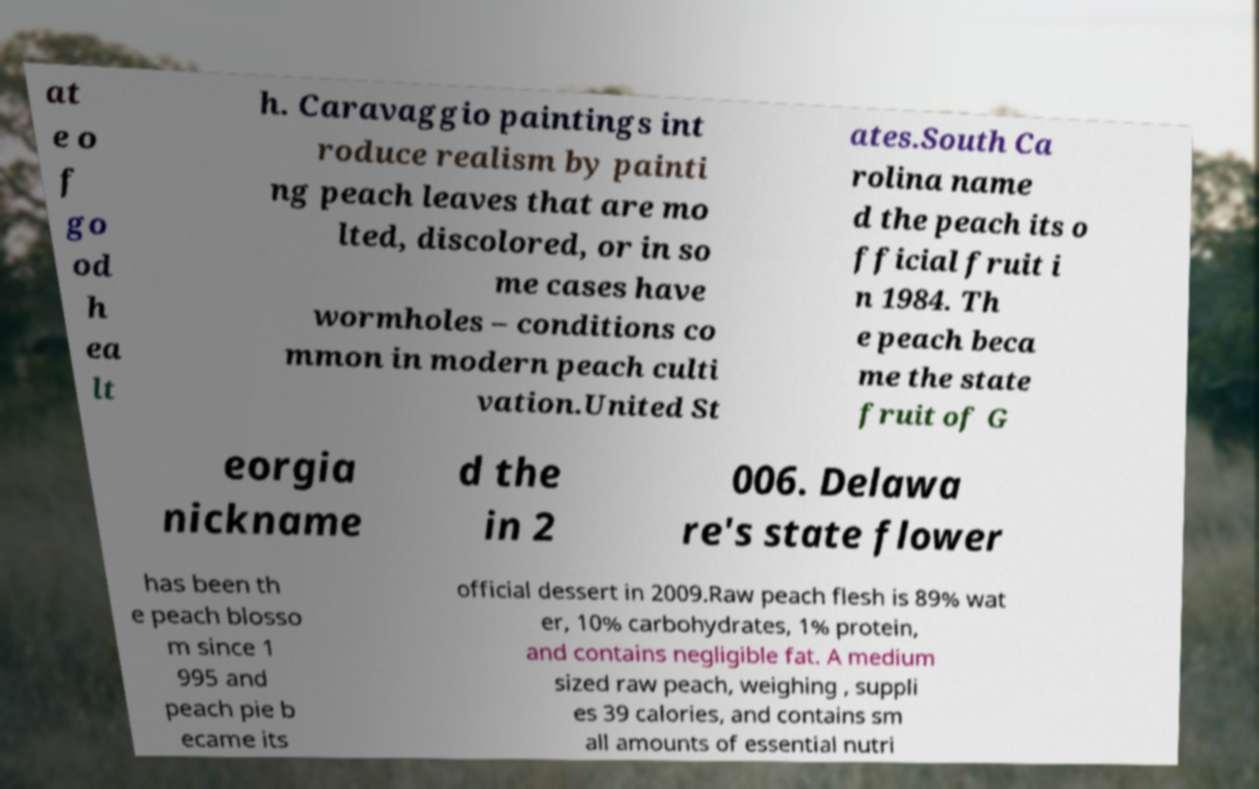Can you accurately transcribe the text from the provided image for me? at e o f go od h ea lt h. Caravaggio paintings int roduce realism by painti ng peach leaves that are mo lted, discolored, or in so me cases have wormholes – conditions co mmon in modern peach culti vation.United St ates.South Ca rolina name d the peach its o fficial fruit i n 1984. Th e peach beca me the state fruit of G eorgia nickname d the in 2 006. Delawa re's state flower has been th e peach blosso m since 1 995 and peach pie b ecame its official dessert in 2009.Raw peach flesh is 89% wat er, 10% carbohydrates, 1% protein, and contains negligible fat. A medium sized raw peach, weighing , suppli es 39 calories, and contains sm all amounts of essential nutri 